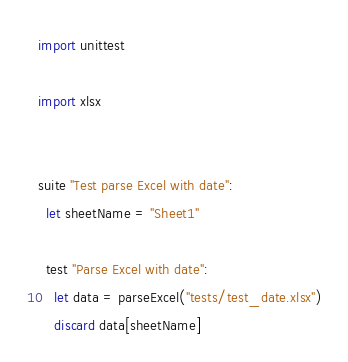<code> <loc_0><loc_0><loc_500><loc_500><_Nim_>import unittest

import xlsx


suite "Test parse Excel with date":
  let sheetName = "Sheet1"

  test "Parse Excel with date":
    let data = parseExcel("tests/test_date.xlsx")
    discard data[sheetName]
</code> 